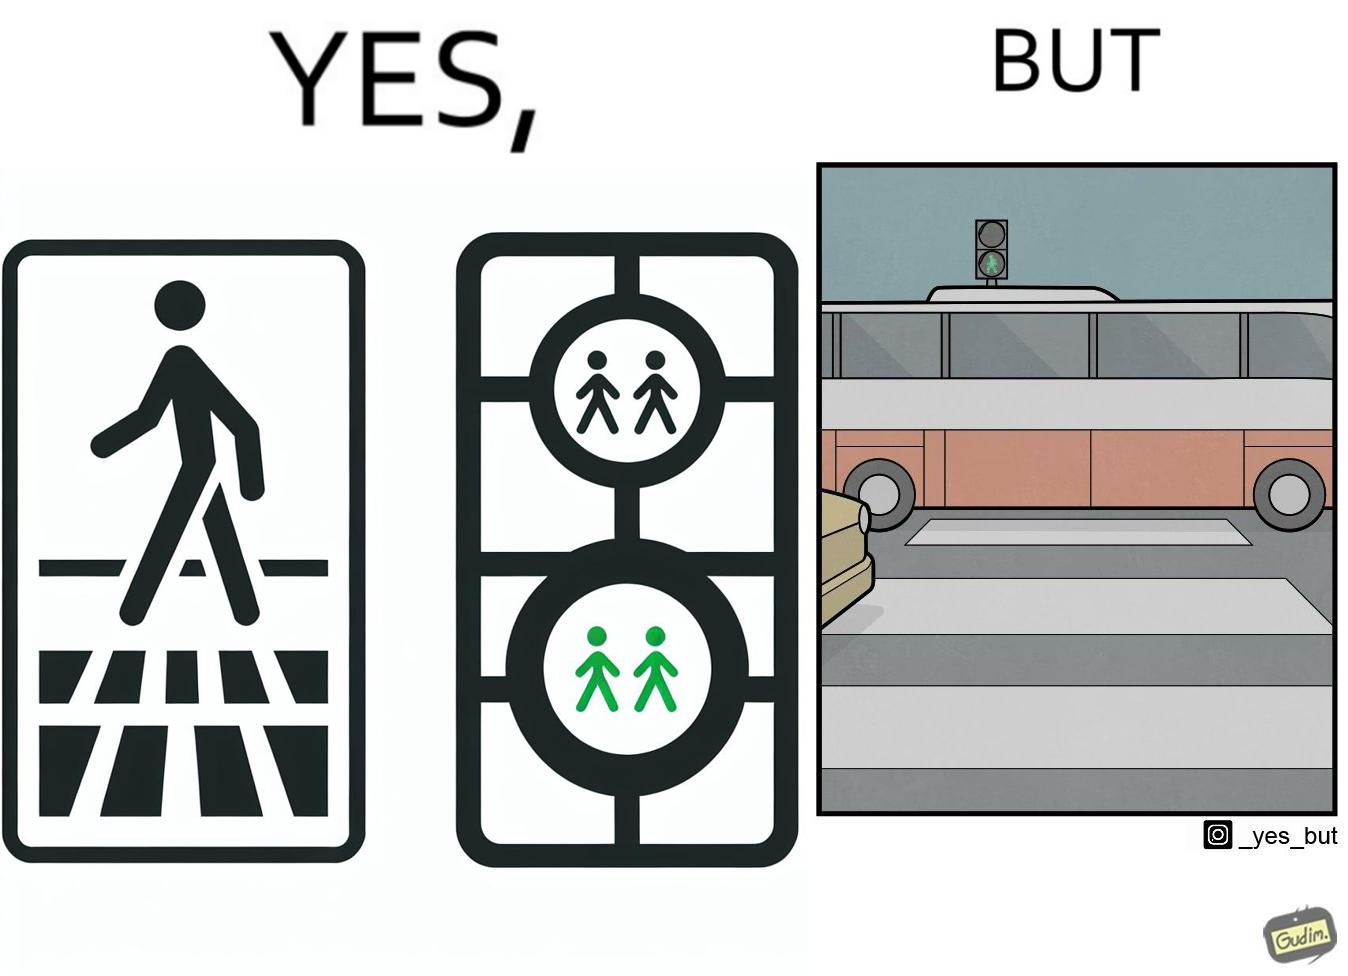Is there satirical content in this image? Yes, this image is satirical. 